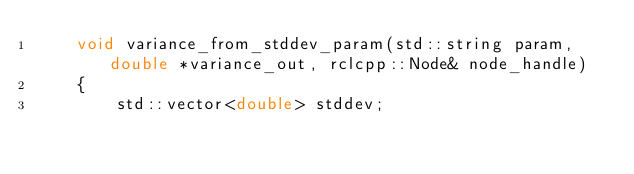Convert code to text. <code><loc_0><loc_0><loc_500><loc_500><_C_>    void variance_from_stddev_param(std::string param, double *variance_out, rclcpp::Node& node_handle)
    {
        std::vector<double> stddev;</code> 